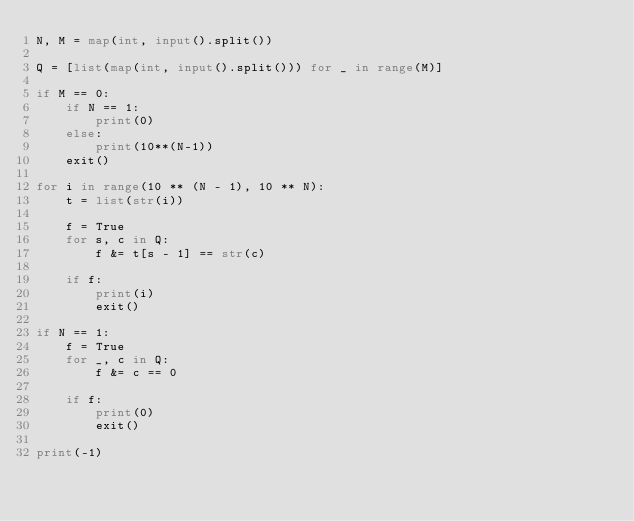Convert code to text. <code><loc_0><loc_0><loc_500><loc_500><_Python_>N, M = map(int, input().split())

Q = [list(map(int, input().split())) for _ in range(M)]

if M == 0:
    if N == 1:
        print(0)
    else:
        print(10**(N-1))
    exit()

for i in range(10 ** (N - 1), 10 ** N):
    t = list(str(i))

    f = True
    for s, c in Q:
        f &= t[s - 1] == str(c)

    if f:
        print(i)
        exit()

if N == 1:
    f = True
    for _, c in Q:
        f &= c == 0

    if f:
        print(0)
        exit()

print(-1)
</code> 